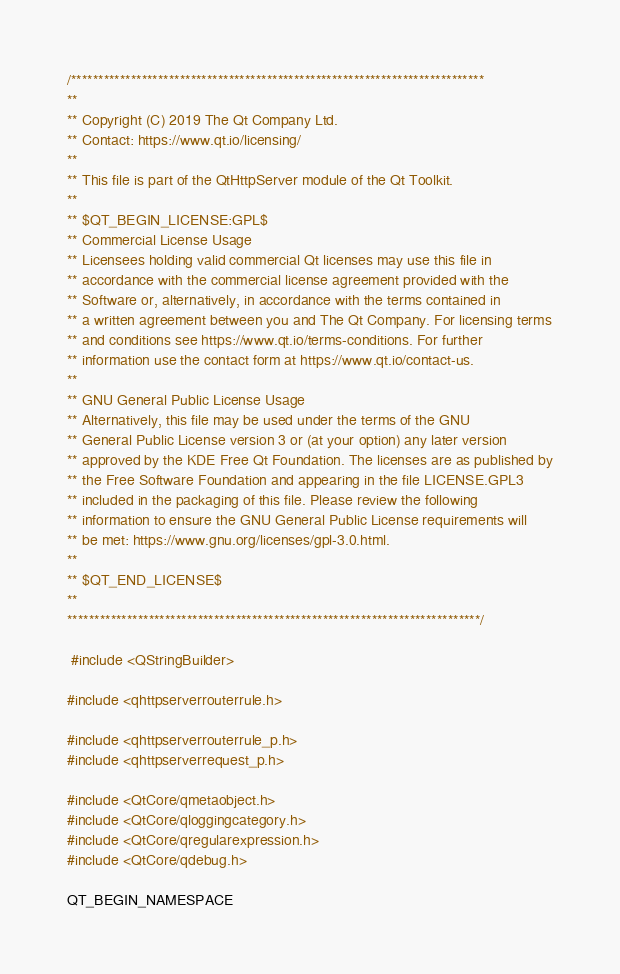<code> <loc_0><loc_0><loc_500><loc_500><_C++_>/****************************************************************************
**
** Copyright (C) 2019 The Qt Company Ltd.
** Contact: https://www.qt.io/licensing/
**
** This file is part of the QtHttpServer module of the Qt Toolkit.
**
** $QT_BEGIN_LICENSE:GPL$
** Commercial License Usage
** Licensees holding valid commercial Qt licenses may use this file in
** accordance with the commercial license agreement provided with the
** Software or, alternatively, in accordance with the terms contained in
** a written agreement between you and The Qt Company. For licensing terms
** and conditions see https://www.qt.io/terms-conditions. For further
** information use the contact form at https://www.qt.io/contact-us.
**
** GNU General Public License Usage
** Alternatively, this file may be used under the terms of the GNU
** General Public License version 3 or (at your option) any later version
** approved by the KDE Free Qt Foundation. The licenses are as published by
** the Free Software Foundation and appearing in the file LICENSE.GPL3
** included in the packaging of this file. Please review the following
** information to ensure the GNU General Public License requirements will
** be met: https://www.gnu.org/licenses/gpl-3.0.html.
**
** $QT_END_LICENSE$
**
****************************************************************************/

 #include <QStringBuilder>

#include <qhttpserverrouterrule.h>

#include <qhttpserverrouterrule_p.h>
#include <qhttpserverrequest_p.h>

#include <QtCore/qmetaobject.h>
#include <QtCore/qloggingcategory.h>
#include <QtCore/qregularexpression.h>
#include <QtCore/qdebug.h>

QT_BEGIN_NAMESPACE
</code> 